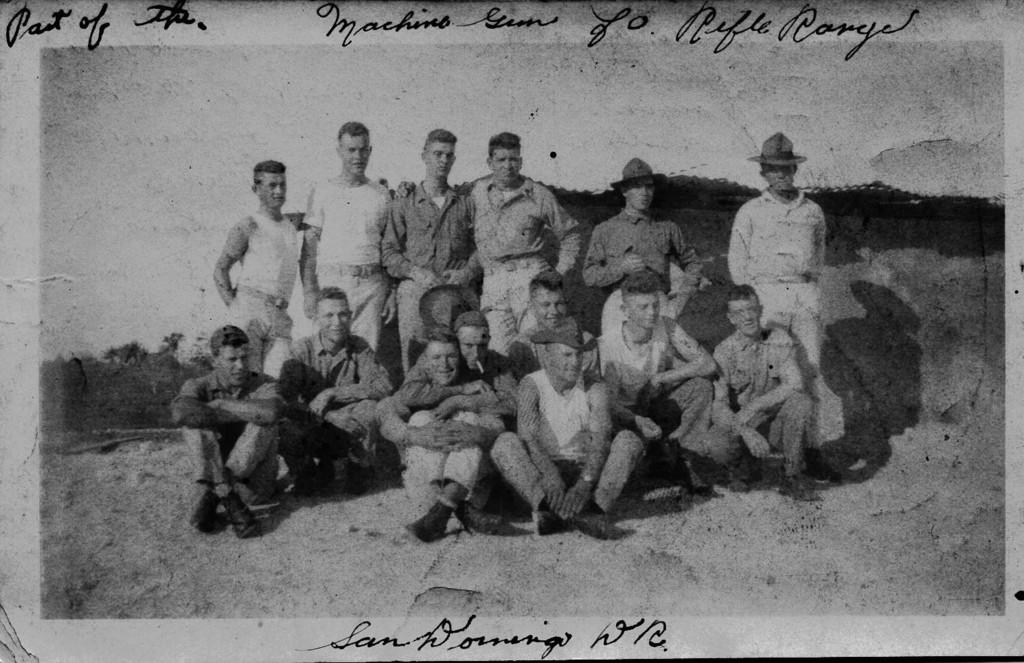What is the color scheme of the image? The image is black and white. What are the people in the image doing? Some people are sitting, and some are standing in the image. Can you describe the clothing of some of the people? Some of the people are wearing hats. What is on the left side of the image? There are trees on the left side of the image. What is visible at the top of the image? The sky is visible at the top of the image. What type of liquid is being poured from the lamp in the image? There is no lamp or liquid present in the image. Who is the achiever in the image? The image does not depict any specific achievements or individuals, so it is not possible to identify an achiever. 